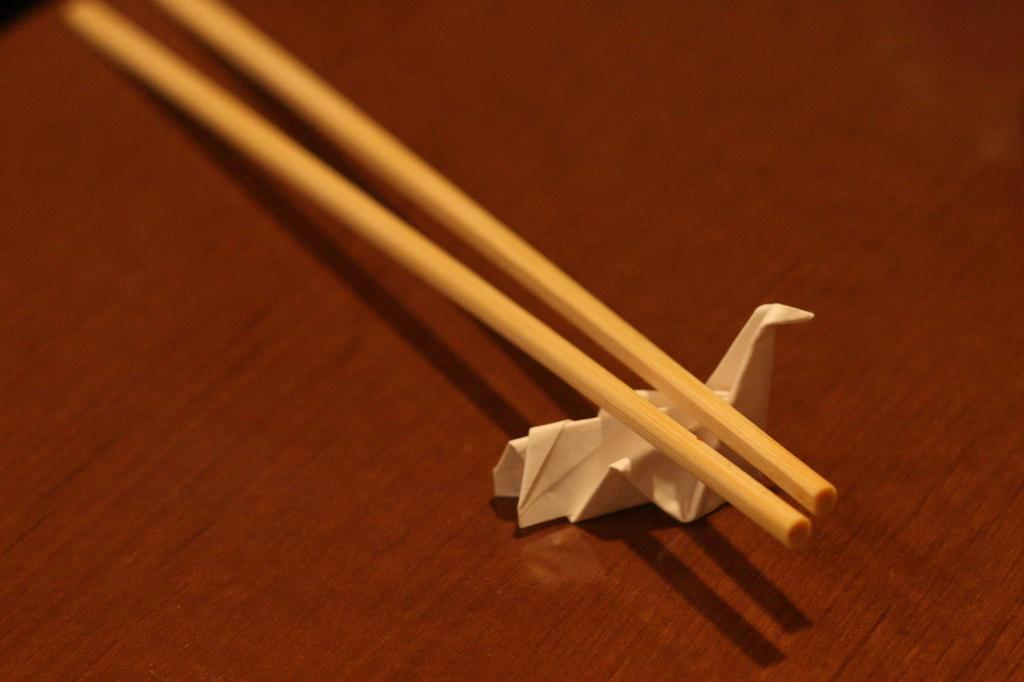What objects can be seen in the image? There are two sticks and a paper on a table in the image. Can you describe the sticks in the image? The image shows two sticks, but no further details about their appearance or purpose are provided. What is the paper on in the image? The paper is on a table in the image. How many lizards are crawling on the paper in the image? There are no lizards present in the image; it only features two sticks and a paper on a table. What type of quilt is covering the table in the image? There is no quilt present in the image; it only features two sticks and a paper on a table. 